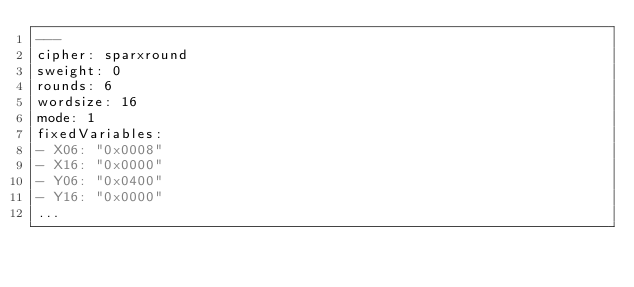Convert code to text. <code><loc_0><loc_0><loc_500><loc_500><_YAML_>---
cipher: sparxround
sweight: 0
rounds: 6
wordsize: 16
mode: 1
fixedVariables:
- X06: "0x0008"
- X16: "0x0000"
- Y06: "0x0400"
- Y16: "0x0000"
...

</code> 